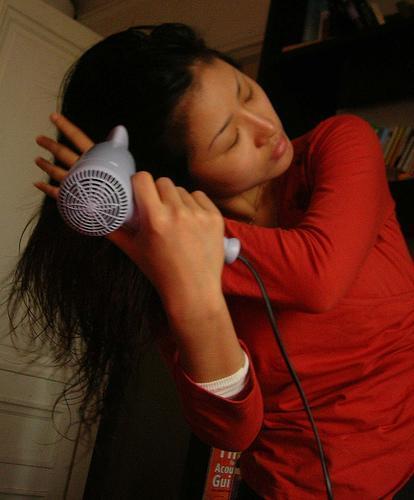How many people are in the photo?
Give a very brief answer. 1. 